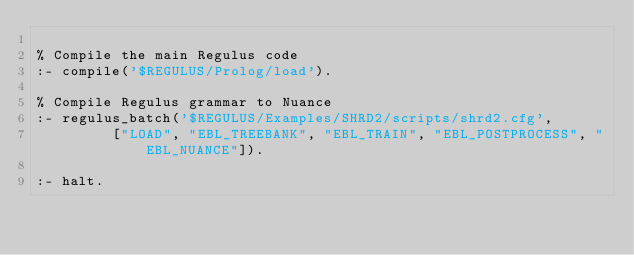<code> <loc_0><loc_0><loc_500><loc_500><_Perl_>
% Compile the main Regulus code
:- compile('$REGULUS/Prolog/load').

% Compile Regulus grammar to Nuance
:- regulus_batch('$REGULUS/Examples/SHRD2/scripts/shrd2.cfg',
		 ["LOAD", "EBL_TREEBANK", "EBL_TRAIN", "EBL_POSTPROCESS", "EBL_NUANCE"]).

:- halt.


</code> 